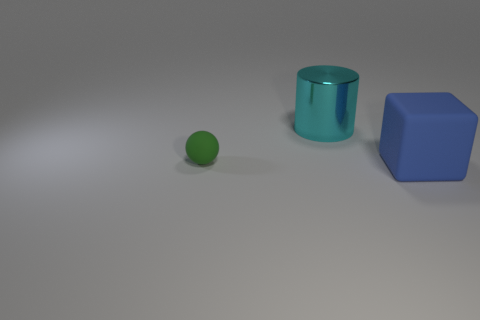There is a object that is on the left side of the large cyan shiny cylinder; what color is it?
Ensure brevity in your answer.  Green. There is a small thing; is its shape the same as the rubber object right of the big shiny cylinder?
Give a very brief answer. No. Is there another big metal thing of the same color as the shiny thing?
Give a very brief answer. No. There is a block that is made of the same material as the small sphere; what is its size?
Offer a terse response. Large. Is the color of the sphere the same as the shiny cylinder?
Your answer should be very brief. No. There is a large thing that is on the left side of the blue block; is it the same shape as the big matte thing?
Keep it short and to the point. No. What number of metal objects are the same size as the cyan cylinder?
Provide a short and direct response. 0. Are there any blocks that are behind the object to the right of the cyan shiny cylinder?
Give a very brief answer. No. What number of things are either big rubber objects in front of the tiny rubber ball or metal cylinders?
Offer a terse response. 2. How many large rubber blocks are there?
Provide a short and direct response. 1. 